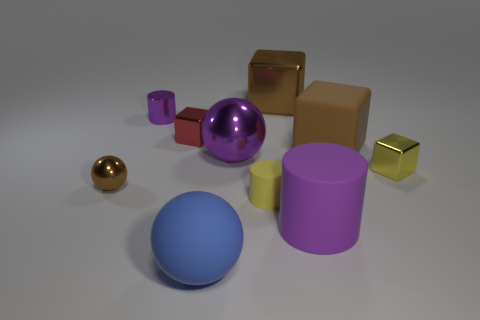What is the color of the small shiny cube in front of the metal block on the left side of the ball behind the small yellow metal cube?
Your response must be concise. Yellow. Is the material of the small yellow block the same as the red cube?
Offer a very short reply. Yes. Does the small brown object have the same shape as the tiny purple metallic thing?
Provide a short and direct response. No. Is the number of small yellow things that are in front of the yellow shiny cube the same as the number of big balls in front of the large blue rubber thing?
Provide a succinct answer. No. What is the color of the big ball that is made of the same material as the yellow block?
Offer a terse response. Purple. What number of tiny blocks have the same material as the brown sphere?
Your answer should be very brief. 2. There is a large metal thing that is behind the big purple metal ball; is it the same color as the matte block?
Keep it short and to the point. Yes. What number of brown metal objects have the same shape as the brown matte object?
Ensure brevity in your answer.  1. Are there the same number of purple rubber cylinders behind the small rubber cylinder and tiny red metal things?
Provide a succinct answer. No. There is a shiny cylinder that is the same size as the brown sphere; what is its color?
Keep it short and to the point. Purple. 